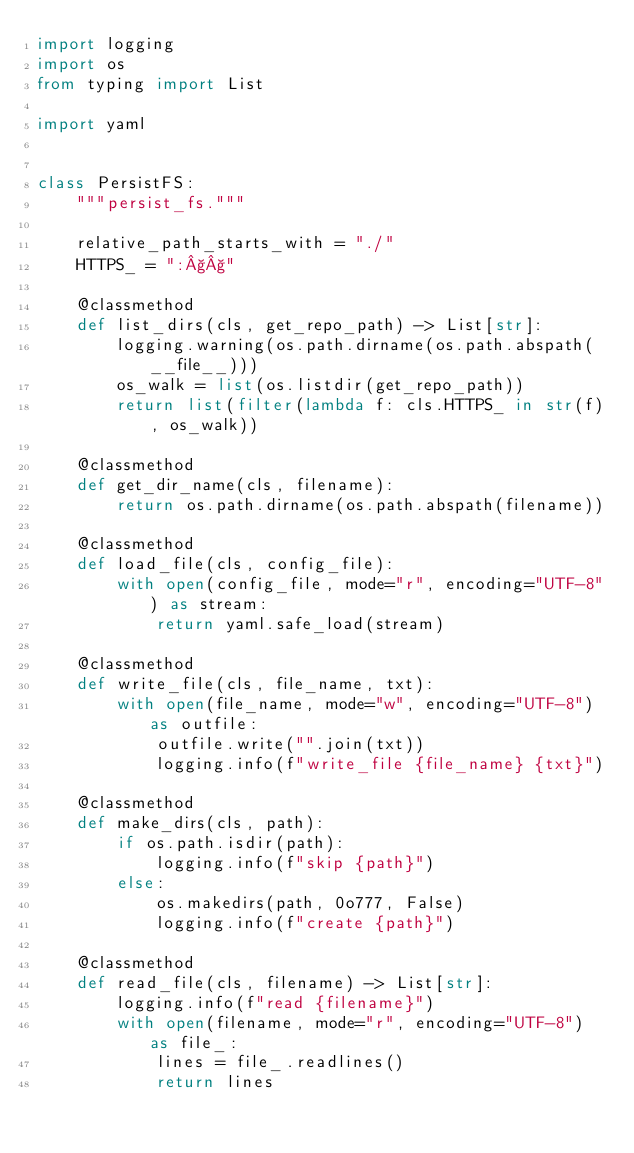<code> <loc_0><loc_0><loc_500><loc_500><_Python_>import logging
import os
from typing import List

import yaml


class PersistFS:
    """persist_fs."""

    relative_path_starts_with = "./"
    HTTPS_ = ":§§"

    @classmethod
    def list_dirs(cls, get_repo_path) -> List[str]:
        logging.warning(os.path.dirname(os.path.abspath(__file__)))
        os_walk = list(os.listdir(get_repo_path))
        return list(filter(lambda f: cls.HTTPS_ in str(f), os_walk))

    @classmethod
    def get_dir_name(cls, filename):
        return os.path.dirname(os.path.abspath(filename))

    @classmethod
    def load_file(cls, config_file):
        with open(config_file, mode="r", encoding="UTF-8") as stream:
            return yaml.safe_load(stream)

    @classmethod
    def write_file(cls, file_name, txt):
        with open(file_name, mode="w", encoding="UTF-8") as outfile:
            outfile.write("".join(txt))
            logging.info(f"write_file {file_name} {txt}")

    @classmethod
    def make_dirs(cls, path):
        if os.path.isdir(path):
            logging.info(f"skip {path}")
        else:
            os.makedirs(path, 0o777, False)
            logging.info(f"create {path}")

    @classmethod
    def read_file(cls, filename) -> List[str]:
        logging.info(f"read {filename}")
        with open(filename, mode="r", encoding="UTF-8") as file_:
            lines = file_.readlines()
            return lines
</code> 